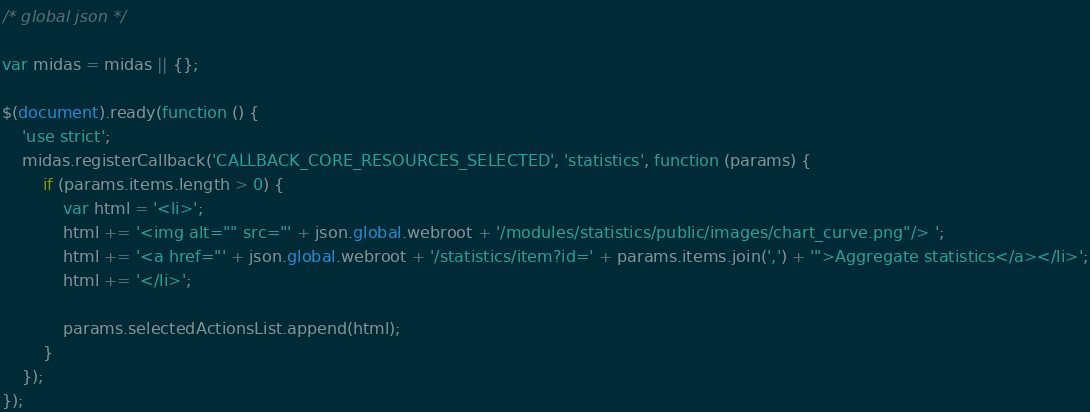Convert code to text. <code><loc_0><loc_0><loc_500><loc_500><_JavaScript_>
/* global json */

var midas = midas || {};

$(document).ready(function () {
    'use strict';
    midas.registerCallback('CALLBACK_CORE_RESOURCES_SELECTED', 'statistics', function (params) {
        if (params.items.length > 0) {
            var html = '<li>';
            html += '<img alt="" src="' + json.global.webroot + '/modules/statistics/public/images/chart_curve.png"/> ';
            html += '<a href="' + json.global.webroot + '/statistics/item?id=' + params.items.join(',') + '">Aggregate statistics</a></li>';
            html += '</li>';

            params.selectedActionsList.append(html);
        }
    });
});
</code> 